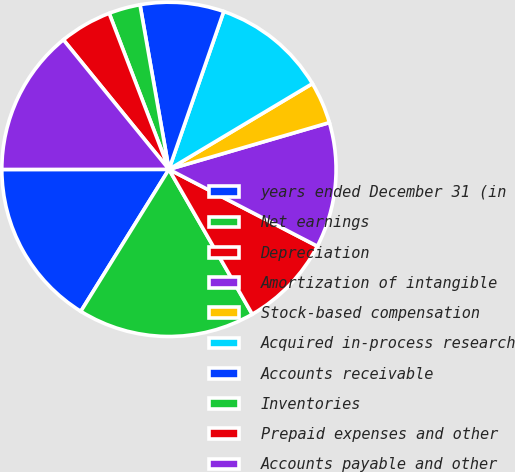Convert chart to OTSL. <chart><loc_0><loc_0><loc_500><loc_500><pie_chart><fcel>years ended December 31 (in<fcel>Net earnings<fcel>Depreciation<fcel>Amortization of intangible<fcel>Stock-based compensation<fcel>Acquired in-process research<fcel>Accounts receivable<fcel>Inventories<fcel>Prepaid expenses and other<fcel>Accounts payable and other<nl><fcel>16.15%<fcel>17.15%<fcel>9.09%<fcel>12.12%<fcel>4.06%<fcel>11.11%<fcel>8.09%<fcel>3.05%<fcel>5.06%<fcel>14.13%<nl></chart> 